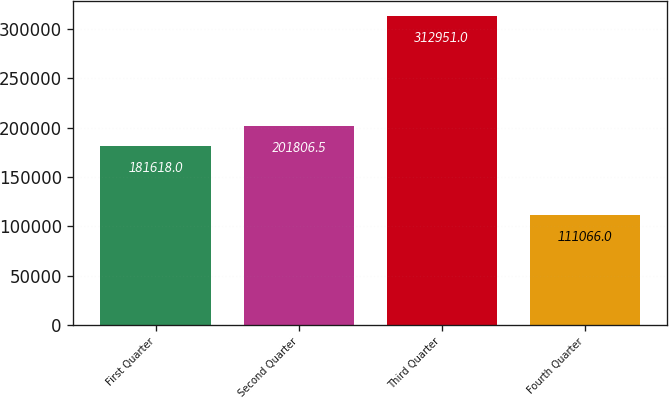Convert chart. <chart><loc_0><loc_0><loc_500><loc_500><bar_chart><fcel>First Quarter<fcel>Second Quarter<fcel>Third Quarter<fcel>Fourth Quarter<nl><fcel>181618<fcel>201806<fcel>312951<fcel>111066<nl></chart> 